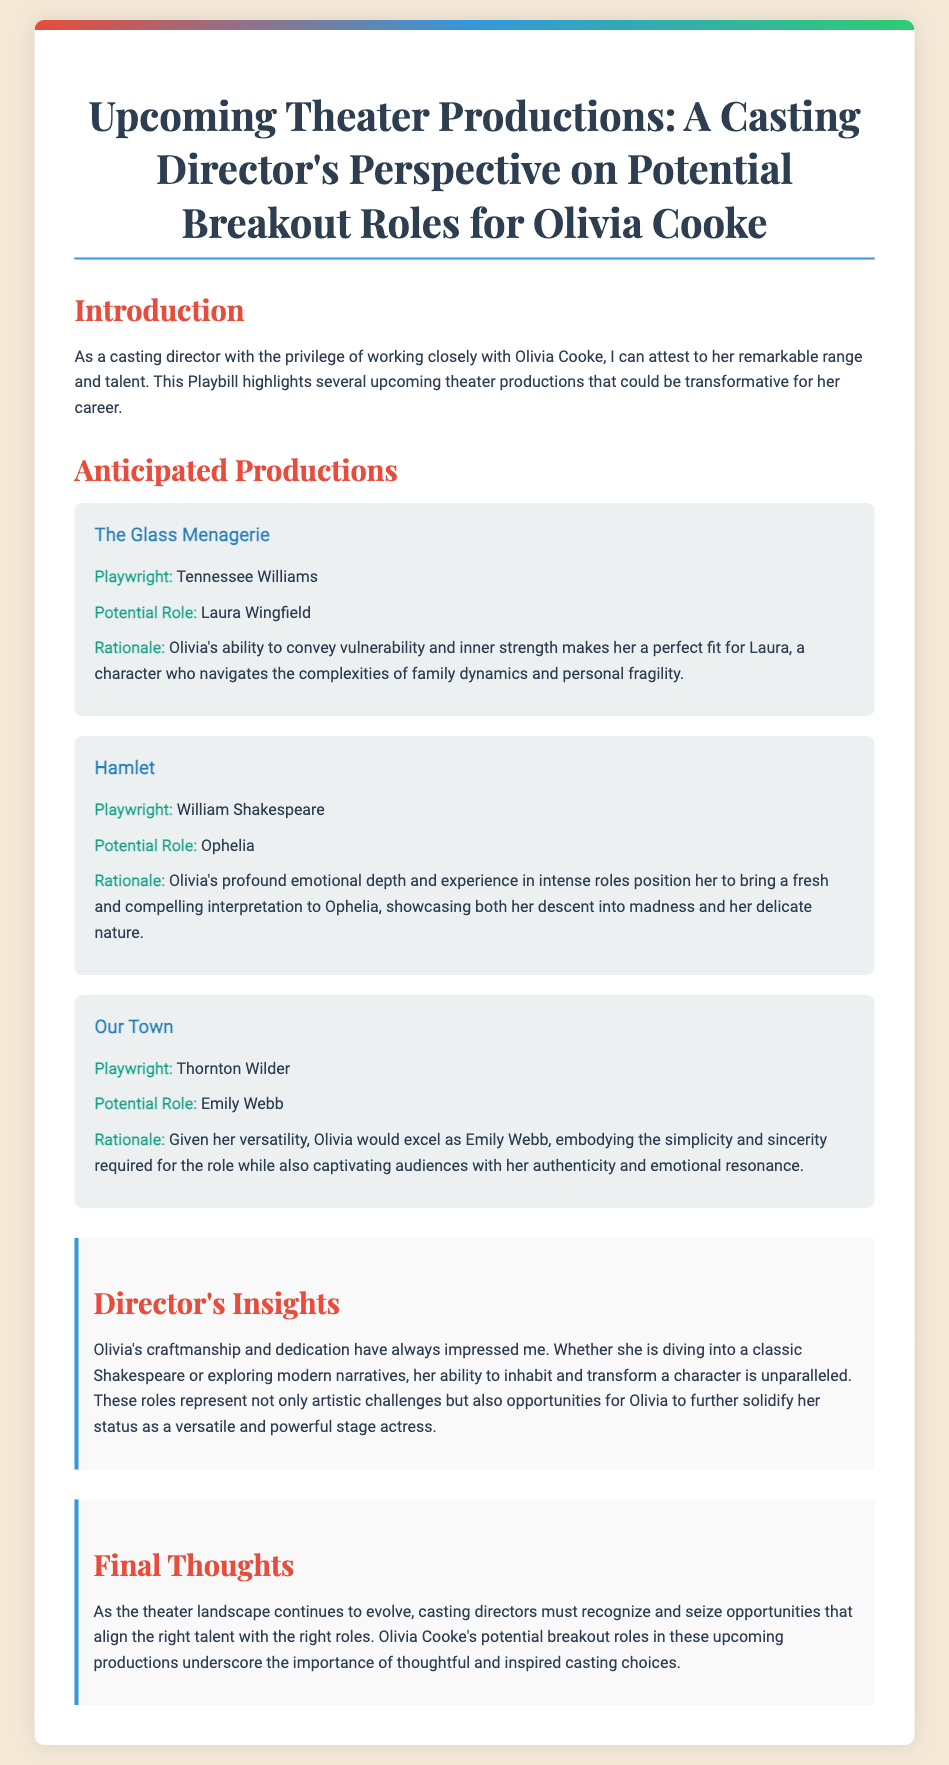What is the title of the Playbill? The title of the Playbill is presented prominently at the top of the document.
Answer: Upcoming Theater Productions: A Casting Director's Perspective on Potential Breakout Roles for Olivia Cooke Who is the playwright of "Hamlet"? "Hamlet" is a classic play by a well-known playwright, which is specifically noted in the production details.
Answer: William Shakespeare What role is suggested for Olivia Cooke in "Our Town"? The document specifies the character Olivia Cooke could potentially portray in "Our Town."
Answer: Emily Webb What is the rationale for casting Olivia as Laura in "The Glass Menagerie"? The rationale provided highlights Olivia's specific qualities that make her suitable for the role, found under that production's description.
Answer: Vulnerability and inner strength Which production features a character that descends into madness? This requires understanding which character's story arc includes significant emotional challenges as described.
Answer: Hamlet (Ophelia) 